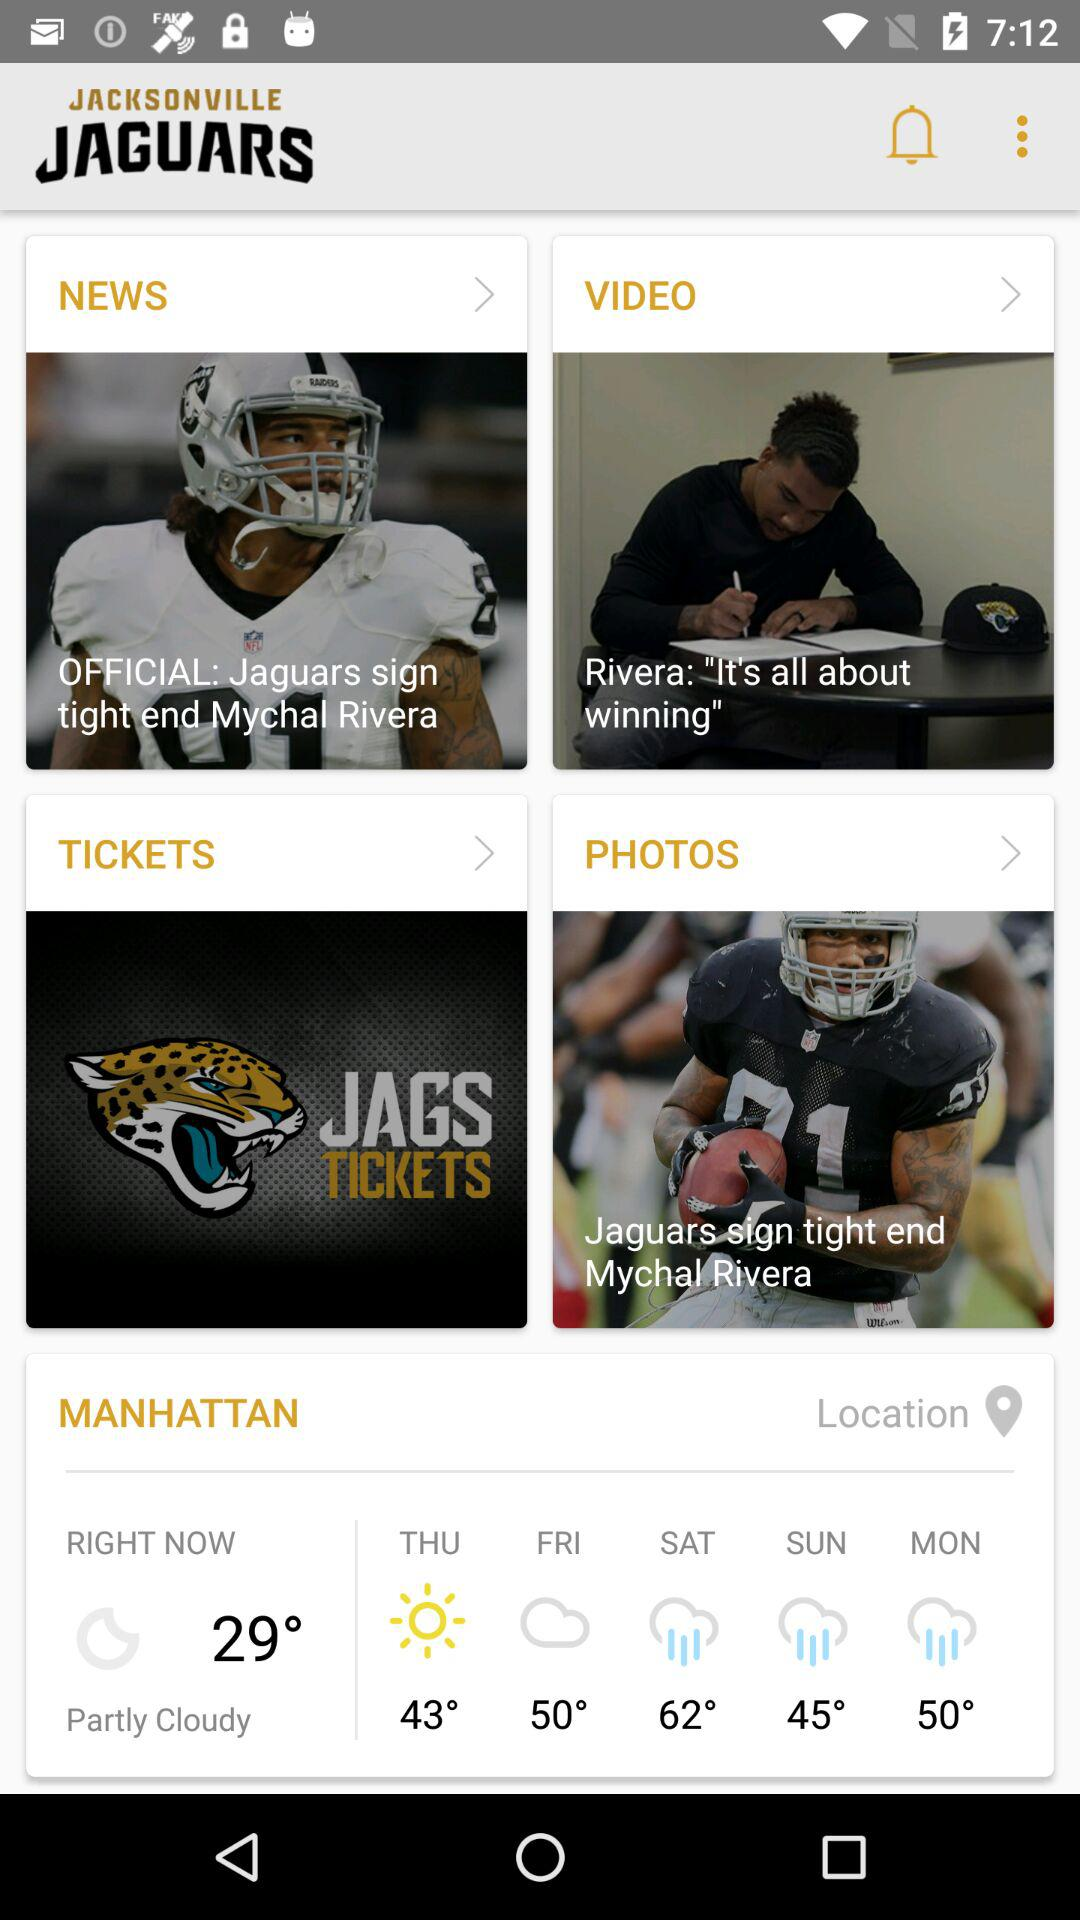What is the location of the weather notification? The location is Manhattan. 